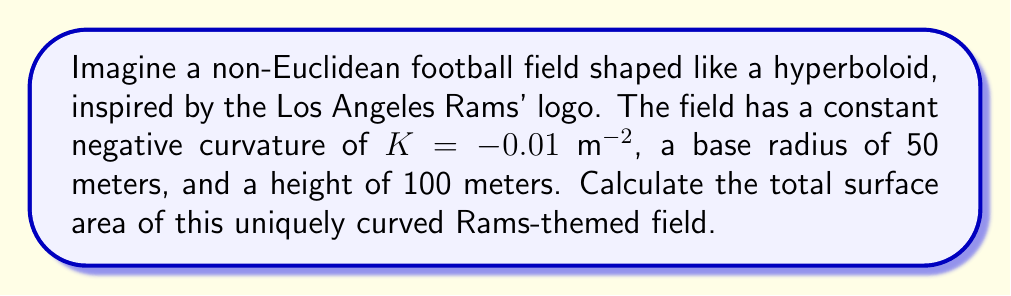Teach me how to tackle this problem. To solve this problem, we'll follow these steps:

1) The surface area of a hyperboloid with constant negative curvature can be calculated using the formula:

   $$A = \frac{4\pi}{|K|} (\cosh(\sqrt{|K|}h) - 1)$$

   Where $K$ is the Gaussian curvature, and $h$ is the height.

2) We're given:
   $K = -0.01$ m⁻²
   $h = 100$ m

3) Let's substitute these values into our formula:

   $$A = \frac{4\pi}{|-0.01|} (\cosh(\sqrt{|-0.01|}100) - 1)$$

4) Simplify:
   $$A = 400\pi (\cosh(\sqrt{0.01}100) - 1)$$
   $$A = 400\pi (\cosh(1) - 1)$$

5) Calculate $\cosh(1)$:
   $$\cosh(1) \approx 1.5430806348152437$$

6) Substitute this value:
   $$A = 400\pi (1.5430806348152437 - 1)$$
   $$A = 400\pi (0.5430806348152437)$$

7) Calculate the final result:
   $$A \approx 682.3519 \text{ m²}$$

Thus, the surface area of the non-Euclidean Rams-inspired football field is approximately 682.3519 square meters.
Answer: $682.3519 \text{ m²}$ 